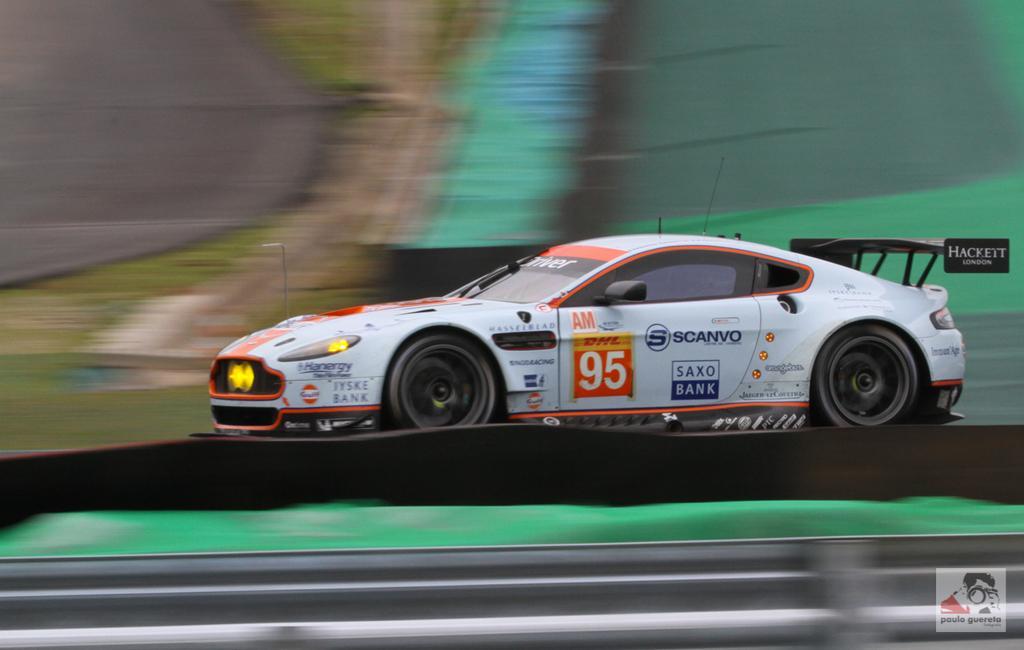Can you describe this image briefly? In this image we can see a car on the road. 